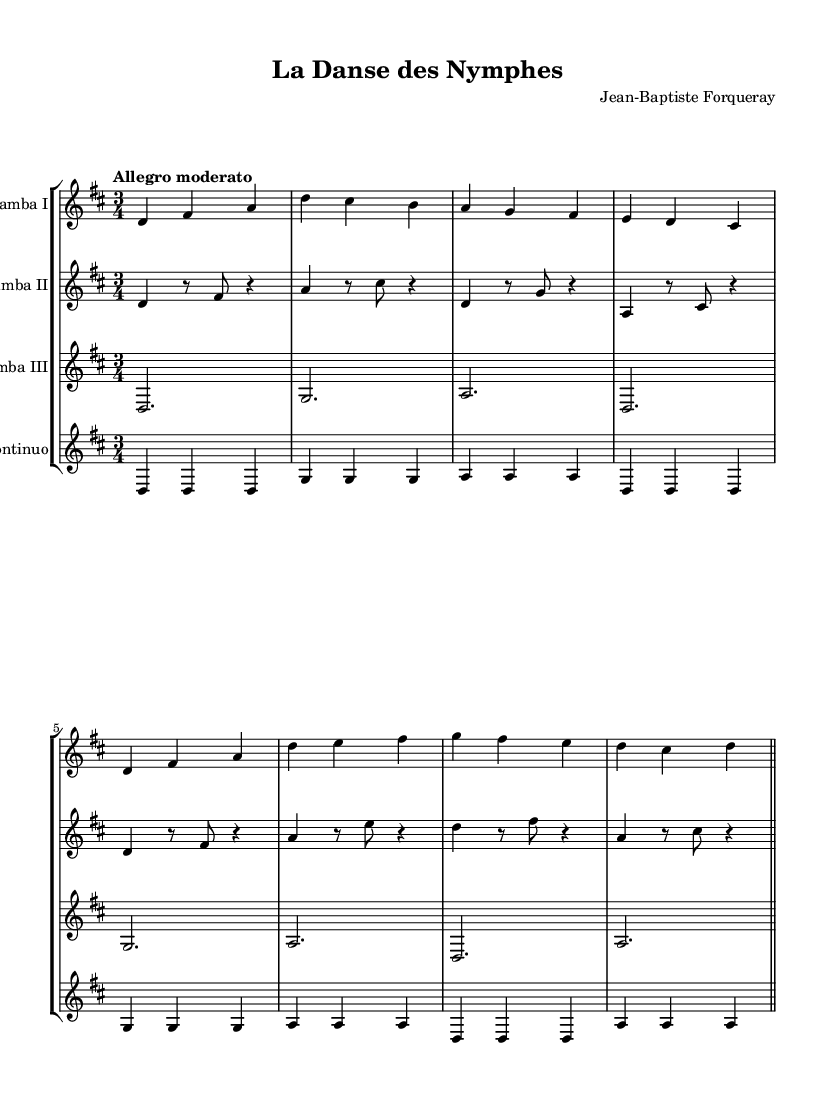What is the key signature of this music? The key signature indicates D major, which has two sharps (F# and C#). This is determined by identifying the key signature at the beginning of the score.
Answer: D major What is the time signature of this music? The time signature is indicated as 3/4, meaning there are three beats per measure and a quarter note receives one beat. This can be found directly at the beginning of the piece.
Answer: 3/4 What is the tempo marking of the piece? The tempo marking is "Allegro moderato," which signifies a moderately fast pace suitable for lively music. This is typically listed at the start of the score.
Answer: Allegro moderato Which instrument plays the highest melody in the score? The highest melody is played by Viola da gamba I, as noted in the clef and the pitch ranges indicated in each staff line, where Viola da gamba I consistently plays higher notes compared to the others.
Answer: Viola da gamba I How many measures are present in the excerpt provided? There are eight measures visible in the score before it concludes, identifiable by the bar lines separating each measure. By counting the spaces between the bar lines, one can determine the total number of measures.
Answer: Eight What kind of ensemble is primarily featured in this piece? The ensemble featured is a viola da gamba ensemble, which is specifically indicated by the designated staves for the viola da gamba instruments and the presence of basso continuo, typical of Baroque chamber music.
Answer: Viola da gamba ensemble 